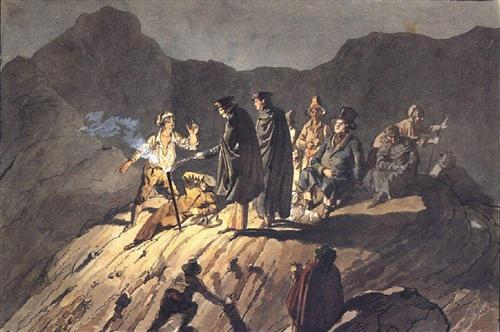What era might this painting represent, and can you identify any potential event or story? This painting likely embodies the Romantic era, characterized by a deep emphasis on emotion and a reverence for the natural world. The scene may represent a historical event from the 18th or early 19th century, possibly an insurrection or a key moment in a historical battle. The characters’ costumes and weapons could be indicative of a specific European conflict during that period, possibly involving figures of significant historical importance. 